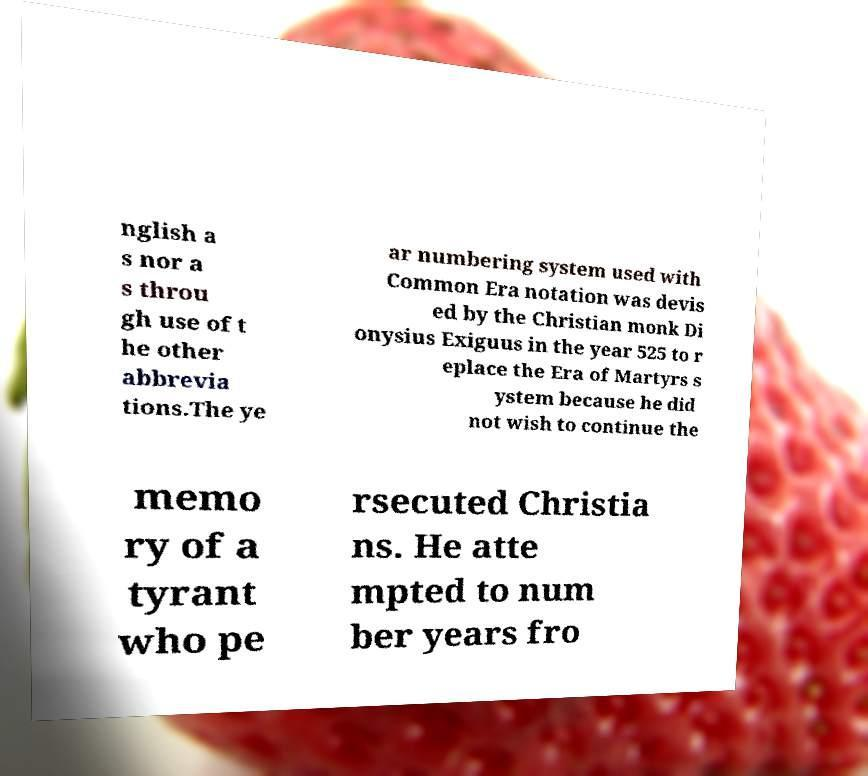For documentation purposes, I need the text within this image transcribed. Could you provide that? nglish a s nor a s throu gh use of t he other abbrevia tions.The ye ar numbering system used with Common Era notation was devis ed by the Christian monk Di onysius Exiguus in the year 525 to r eplace the Era of Martyrs s ystem because he did not wish to continue the memo ry of a tyrant who pe rsecuted Christia ns. He atte mpted to num ber years fro 